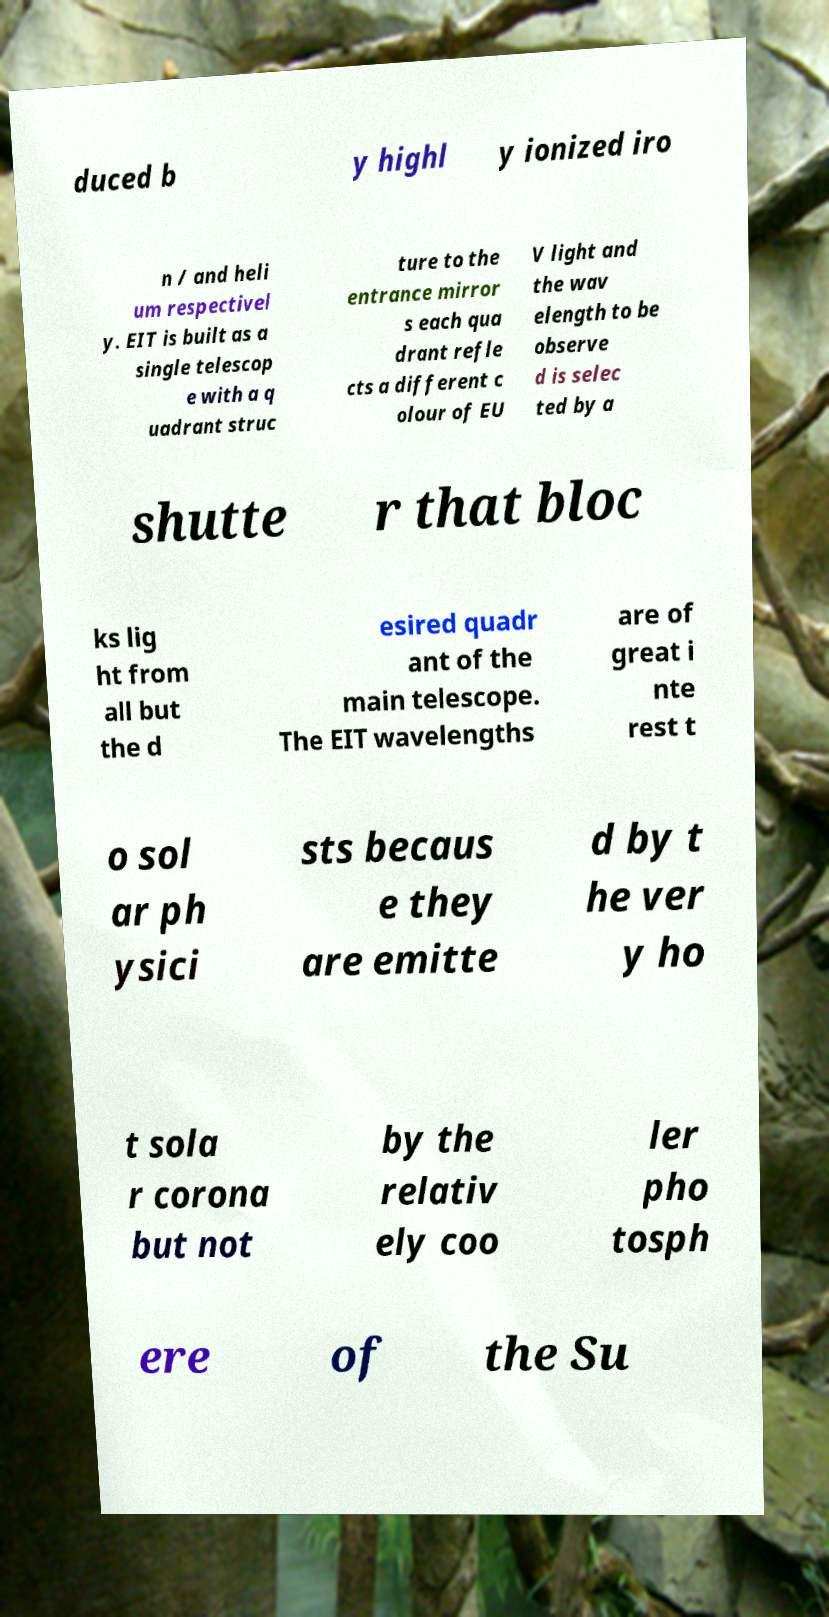Could you extract and type out the text from this image? duced b y highl y ionized iro n / and heli um respectivel y. EIT is built as a single telescop e with a q uadrant struc ture to the entrance mirror s each qua drant refle cts a different c olour of EU V light and the wav elength to be observe d is selec ted by a shutte r that bloc ks lig ht from all but the d esired quadr ant of the main telescope. The EIT wavelengths are of great i nte rest t o sol ar ph ysici sts becaus e they are emitte d by t he ver y ho t sola r corona but not by the relativ ely coo ler pho tosph ere of the Su 